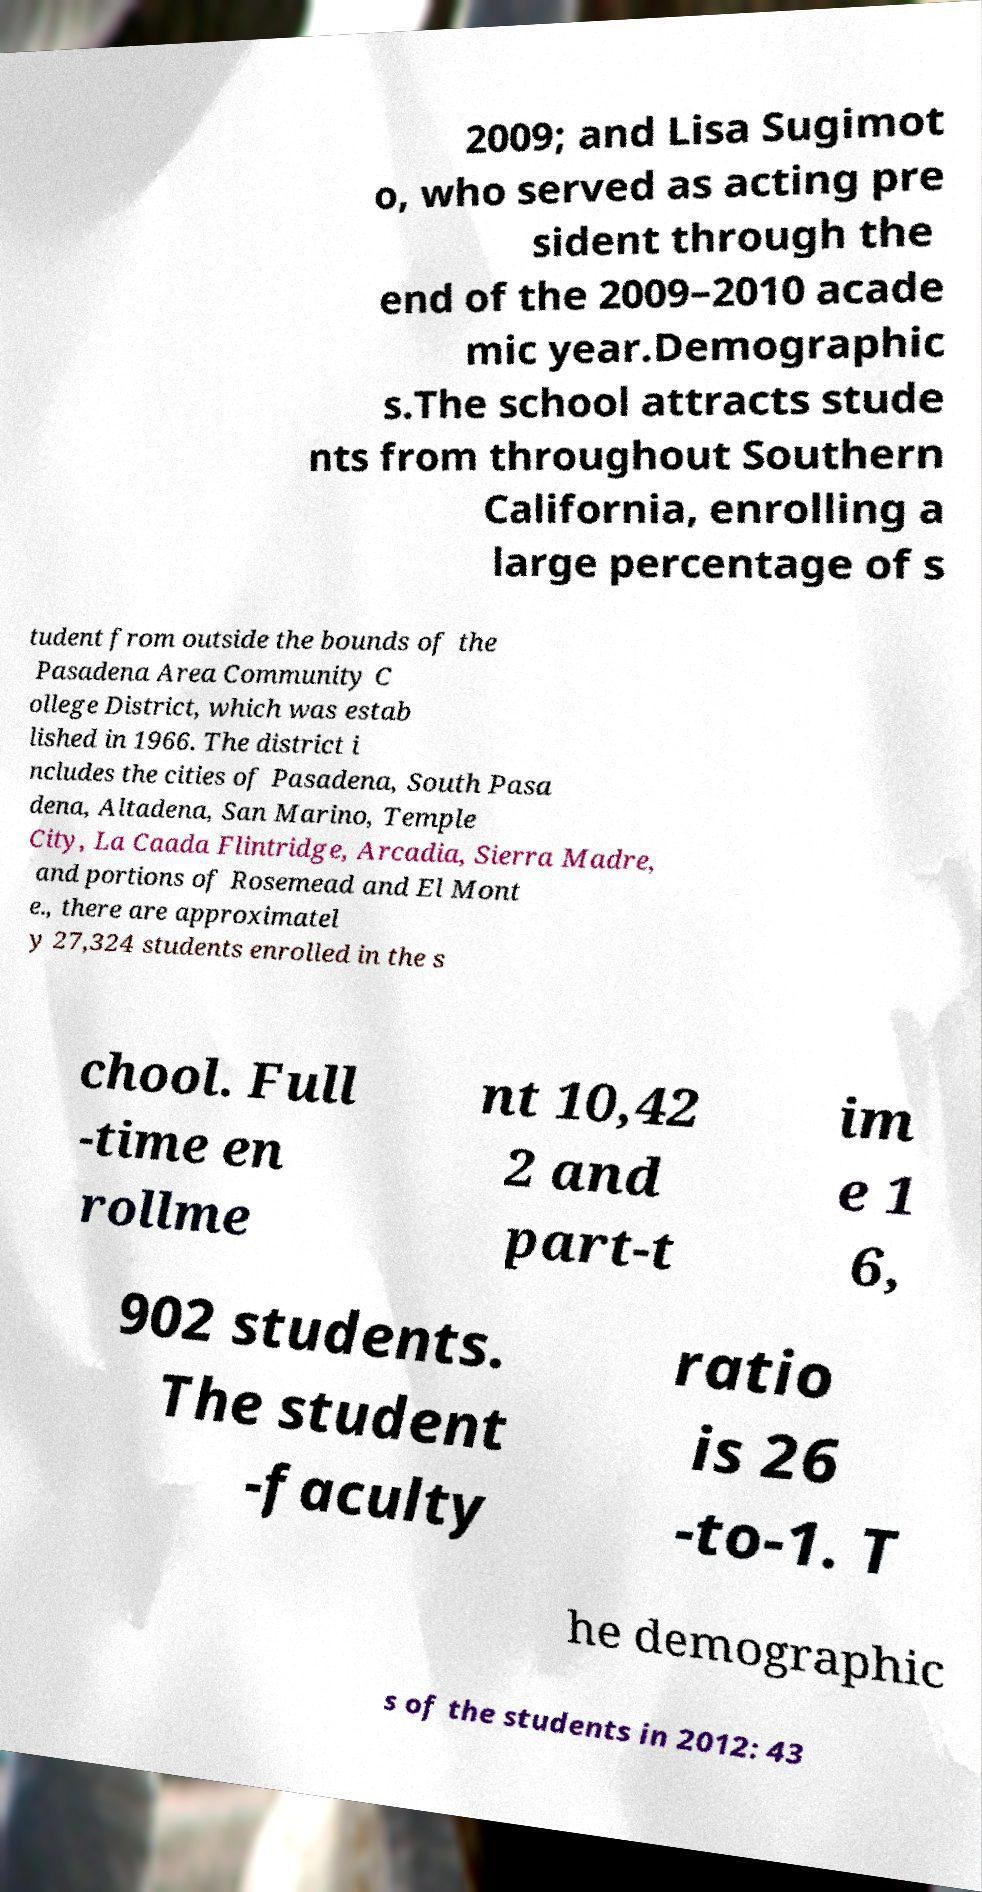Could you assist in decoding the text presented in this image and type it out clearly? 2009; and Lisa Sugimot o, who served as acting pre sident through the end of the 2009–2010 acade mic year.Demographic s.The school attracts stude nts from throughout Southern California, enrolling a large percentage of s tudent from outside the bounds of the Pasadena Area Community C ollege District, which was estab lished in 1966. The district i ncludes the cities of Pasadena, South Pasa dena, Altadena, San Marino, Temple City, La Caada Flintridge, Arcadia, Sierra Madre, and portions of Rosemead and El Mont e., there are approximatel y 27,324 students enrolled in the s chool. Full -time en rollme nt 10,42 2 and part-t im e 1 6, 902 students. The student -faculty ratio is 26 -to-1. T he demographic s of the students in 2012: 43 